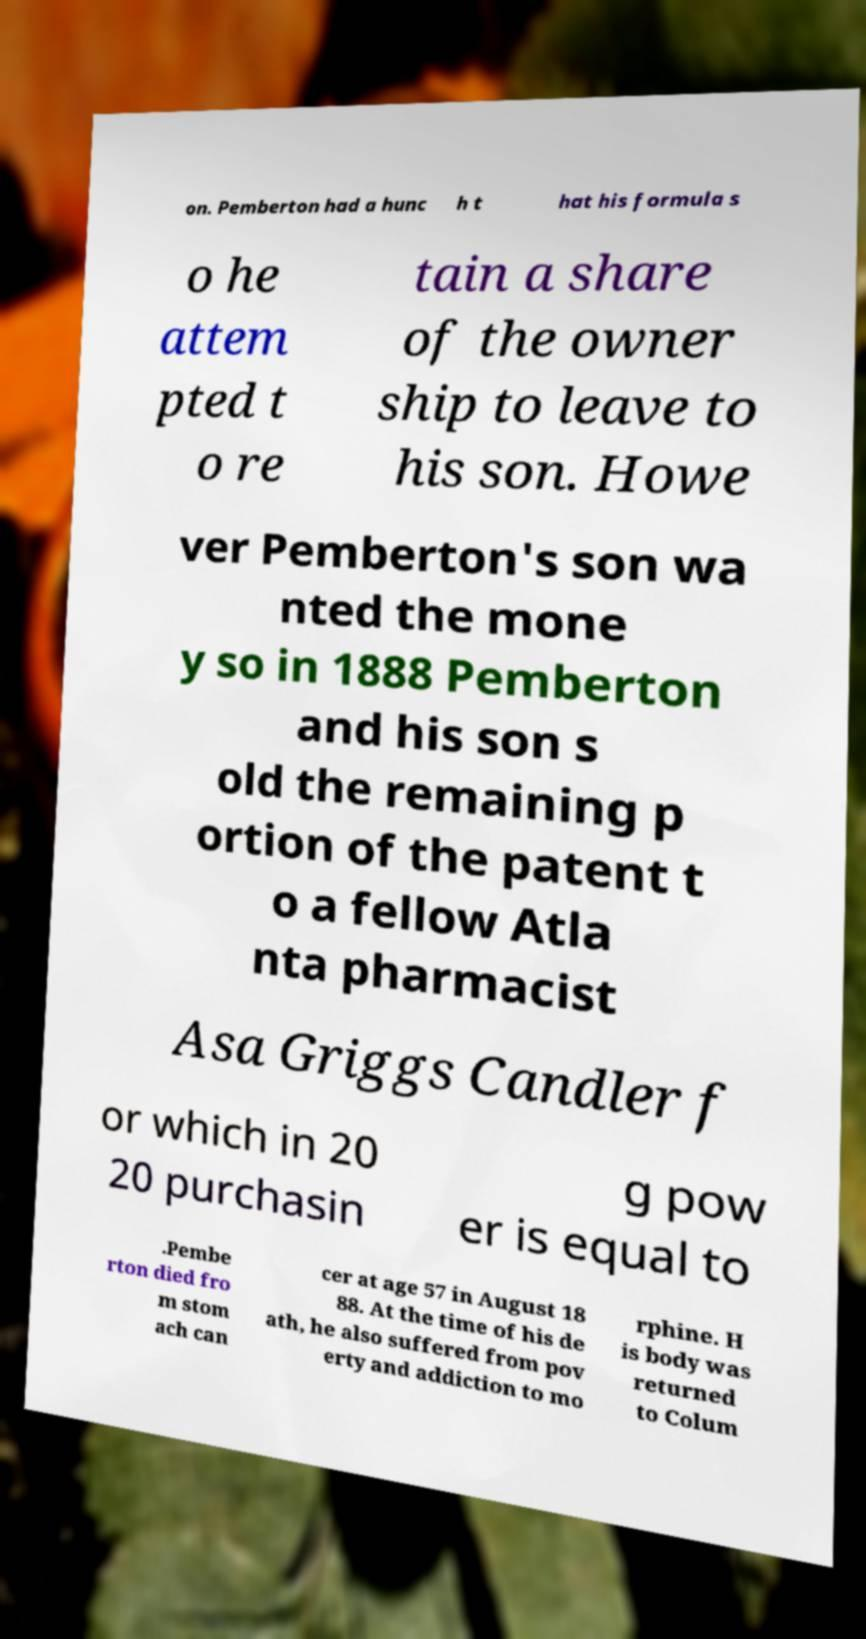Can you accurately transcribe the text from the provided image for me? on. Pemberton had a hunc h t hat his formula s o he attem pted t o re tain a share of the owner ship to leave to his son. Howe ver Pemberton's son wa nted the mone y so in 1888 Pemberton and his son s old the remaining p ortion of the patent t o a fellow Atla nta pharmacist Asa Griggs Candler f or which in 20 20 purchasin g pow er is equal to .Pembe rton died fro m stom ach can cer at age 57 in August 18 88. At the time of his de ath, he also suffered from pov erty and addiction to mo rphine. H is body was returned to Colum 